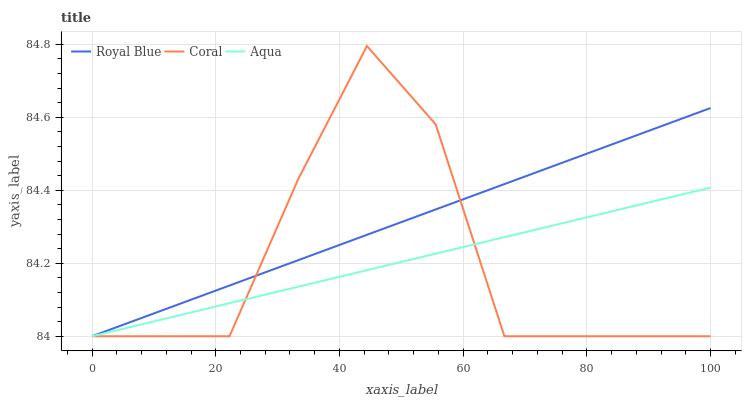Does Coral have the minimum area under the curve?
Answer yes or no. Yes. Does Royal Blue have the maximum area under the curve?
Answer yes or no. Yes. Does Aqua have the minimum area under the curve?
Answer yes or no. No. Does Aqua have the maximum area under the curve?
Answer yes or no. No. Is Aqua the smoothest?
Answer yes or no. Yes. Is Coral the roughest?
Answer yes or no. Yes. Is Coral the smoothest?
Answer yes or no. No. Is Aqua the roughest?
Answer yes or no. No. Does Coral have the highest value?
Answer yes or no. Yes. Does Aqua have the highest value?
Answer yes or no. No. Does Aqua intersect Royal Blue?
Answer yes or no. Yes. Is Aqua less than Royal Blue?
Answer yes or no. No. Is Aqua greater than Royal Blue?
Answer yes or no. No. 